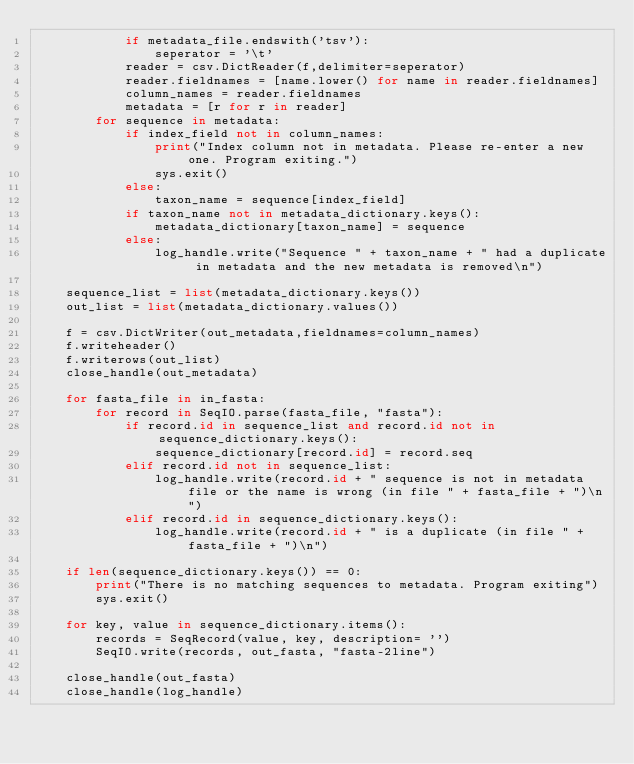<code> <loc_0><loc_0><loc_500><loc_500><_Python_>            if metadata_file.endswith('tsv'):
                seperator = '\t'
            reader = csv.DictReader(f,delimiter=seperator)
            reader.fieldnames = [name.lower() for name in reader.fieldnames]
            column_names = reader.fieldnames
            metadata = [r for r in reader]
        for sequence in metadata:
            if index_field not in column_names:
                print("Index column not in metadata. Please re-enter a new one. Program exiting.")
                sys.exit()
            else:
                taxon_name = sequence[index_field]
            if taxon_name not in metadata_dictionary.keys():
                metadata_dictionary[taxon_name] = sequence
            else:
                log_handle.write("Sequence " + taxon_name + " had a duplicate in metadata and the new metadata is removed\n")

    sequence_list = list(metadata_dictionary.keys())
    out_list = list(metadata_dictionary.values())

    f = csv.DictWriter(out_metadata,fieldnames=column_names)
    f.writeheader()
    f.writerows(out_list)
    close_handle(out_metadata)

    for fasta_file in in_fasta:
        for record in SeqIO.parse(fasta_file, "fasta"):
            if record.id in sequence_list and record.id not in sequence_dictionary.keys():
                sequence_dictionary[record.id] = record.seq
            elif record.id not in sequence_list:
                log_handle.write(record.id + " sequence is not in metadata file or the name is wrong (in file " + fasta_file + ")\n")
            elif record.id in sequence_dictionary.keys():
                log_handle.write(record.id + " is a duplicate (in file " + fasta_file + ")\n")

    if len(sequence_dictionary.keys()) == 0:
        print("There is no matching sequences to metadata. Program exiting")
        sys.exit()

    for key, value in sequence_dictionary.items():
        records = SeqRecord(value, key, description= '')
        SeqIO.write(records, out_fasta, "fasta-2line")

    close_handle(out_fasta)
    close_handle(log_handle)
</code> 